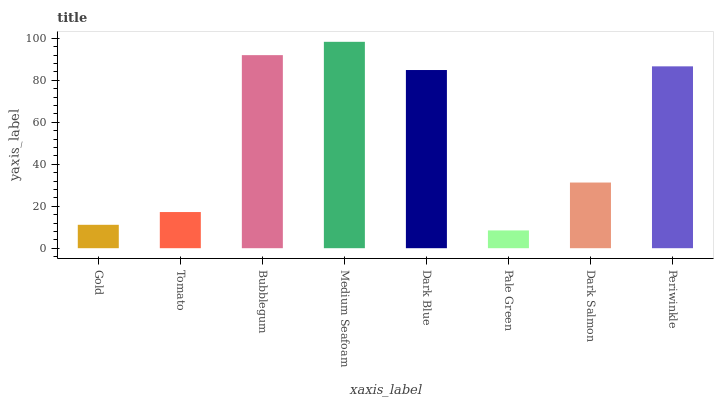Is Tomato the minimum?
Answer yes or no. No. Is Tomato the maximum?
Answer yes or no. No. Is Tomato greater than Gold?
Answer yes or no. Yes. Is Gold less than Tomato?
Answer yes or no. Yes. Is Gold greater than Tomato?
Answer yes or no. No. Is Tomato less than Gold?
Answer yes or no. No. Is Dark Blue the high median?
Answer yes or no. Yes. Is Dark Salmon the low median?
Answer yes or no. Yes. Is Dark Salmon the high median?
Answer yes or no. No. Is Periwinkle the low median?
Answer yes or no. No. 